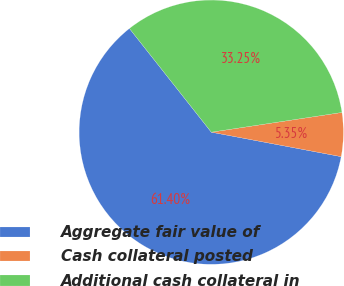<chart> <loc_0><loc_0><loc_500><loc_500><pie_chart><fcel>Aggregate fair value of<fcel>Cash collateral posted<fcel>Additional cash collateral in<nl><fcel>61.4%<fcel>5.35%<fcel>33.25%<nl></chart> 